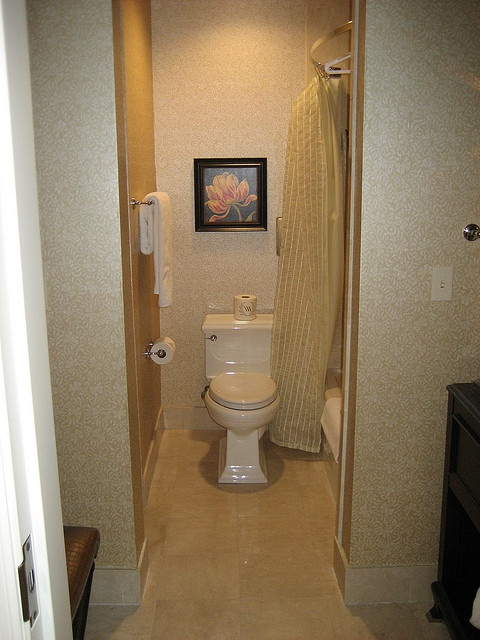Describe the objects in this image and their specific colors. I can see a toilet in lightgray, tan, gray, and maroon tones in this image. 